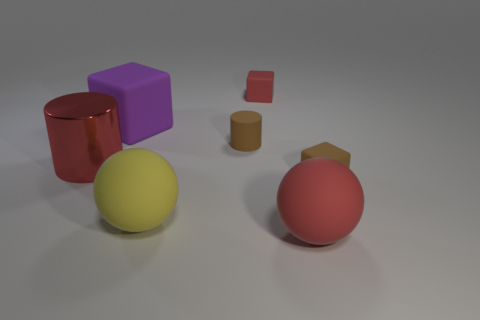Add 2 purple cubes. How many objects exist? 9 Subtract all balls. How many objects are left? 5 Subtract 1 red cylinders. How many objects are left? 6 Subtract all large yellow matte spheres. Subtract all big rubber spheres. How many objects are left? 4 Add 1 small matte blocks. How many small matte blocks are left? 3 Add 1 tiny cylinders. How many tiny cylinders exist? 2 